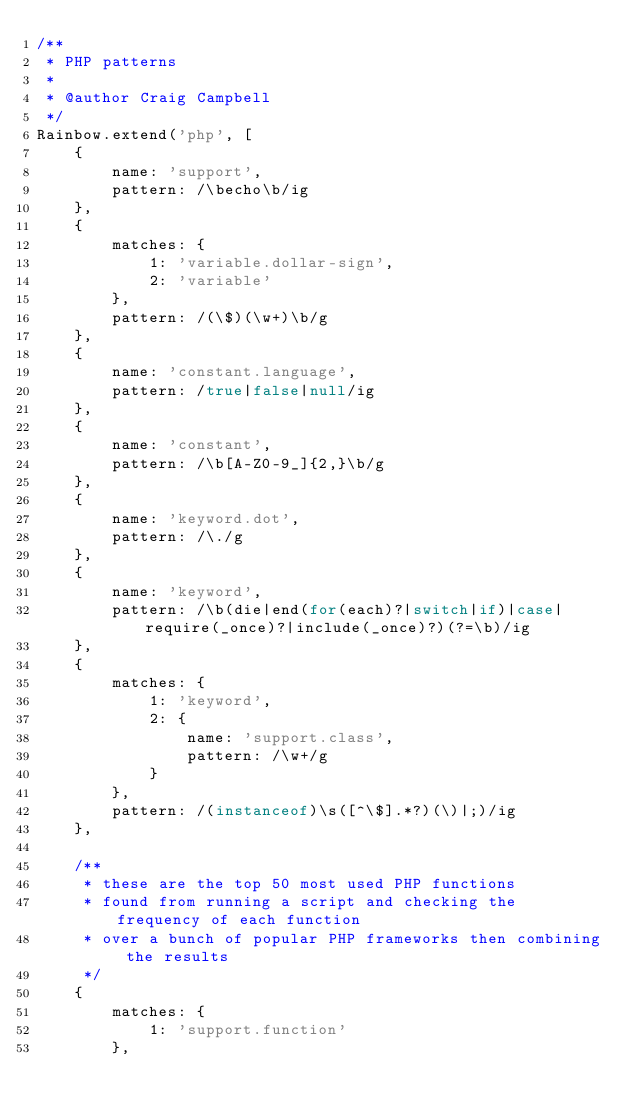Convert code to text. <code><loc_0><loc_0><loc_500><loc_500><_JavaScript_>/**
 * PHP patterns
 *
 * @author Craig Campbell
 */
Rainbow.extend('php', [
    {
        name: 'support',
        pattern: /\becho\b/ig
    },
    {
        matches: {
            1: 'variable.dollar-sign',
            2: 'variable'
        },
        pattern: /(\$)(\w+)\b/g
    },
    {
        name: 'constant.language',
        pattern: /true|false|null/ig
    },
    {
        name: 'constant',
        pattern: /\b[A-Z0-9_]{2,}\b/g
    },
    {
        name: 'keyword.dot',
        pattern: /\./g
    },
    {
        name: 'keyword',
        pattern: /\b(die|end(for(each)?|switch|if)|case|require(_once)?|include(_once)?)(?=\b)/ig
    },
    {
        matches: {
            1: 'keyword',
            2: {
                name: 'support.class',
                pattern: /\w+/g
            }
        },
        pattern: /(instanceof)\s([^\$].*?)(\)|;)/ig
    },

    /**
     * these are the top 50 most used PHP functions
     * found from running a script and checking the frequency of each function
     * over a bunch of popular PHP frameworks then combining the results
     */
    {
        matches: {
            1: 'support.function'
        },</code> 